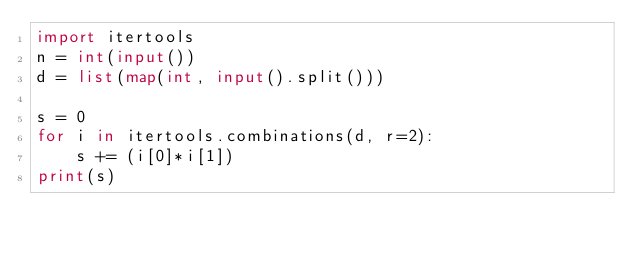<code> <loc_0><loc_0><loc_500><loc_500><_Python_>import itertools
n = int(input())
d = list(map(int, input().split()))

s = 0
for i in itertools.combinations(d, r=2):
    s += (i[0]*i[1])
print(s)</code> 